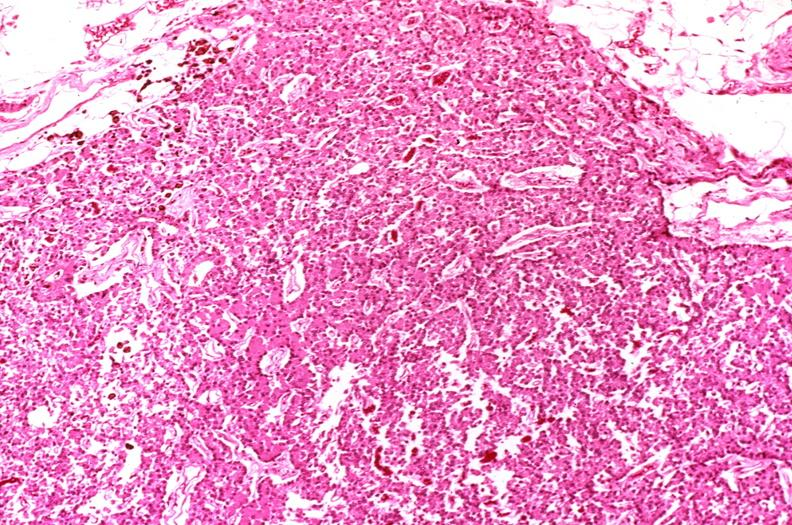what does this image show?
Answer the question using a single word or phrase. Parathyroid 